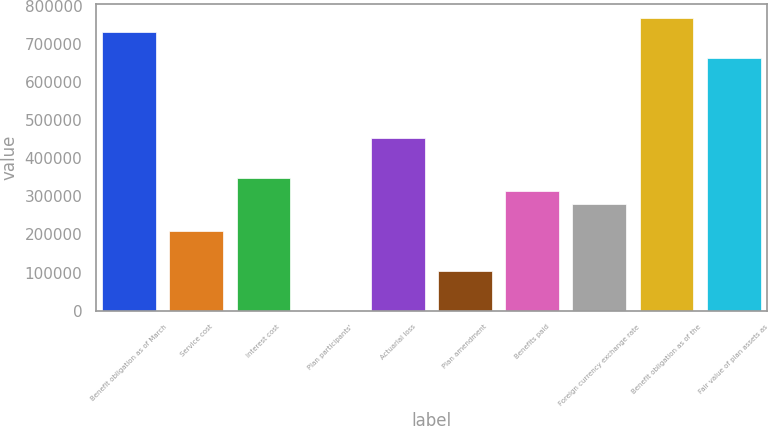Convert chart to OTSL. <chart><loc_0><loc_0><loc_500><loc_500><bar_chart><fcel>Benefit obligation as of March<fcel>Service cost<fcel>Interest cost<fcel>Plan participants'<fcel>Actuarial loss<fcel>Plan amendment<fcel>Benefits paid<fcel>Foreign currency exchange rate<fcel>Benefit obligation as of the<fcel>Fair value of plan assets as<nl><fcel>732997<fcel>209488<fcel>349090<fcel>84<fcel>453792<fcel>104786<fcel>314189<fcel>279289<fcel>767897<fcel>663195<nl></chart> 